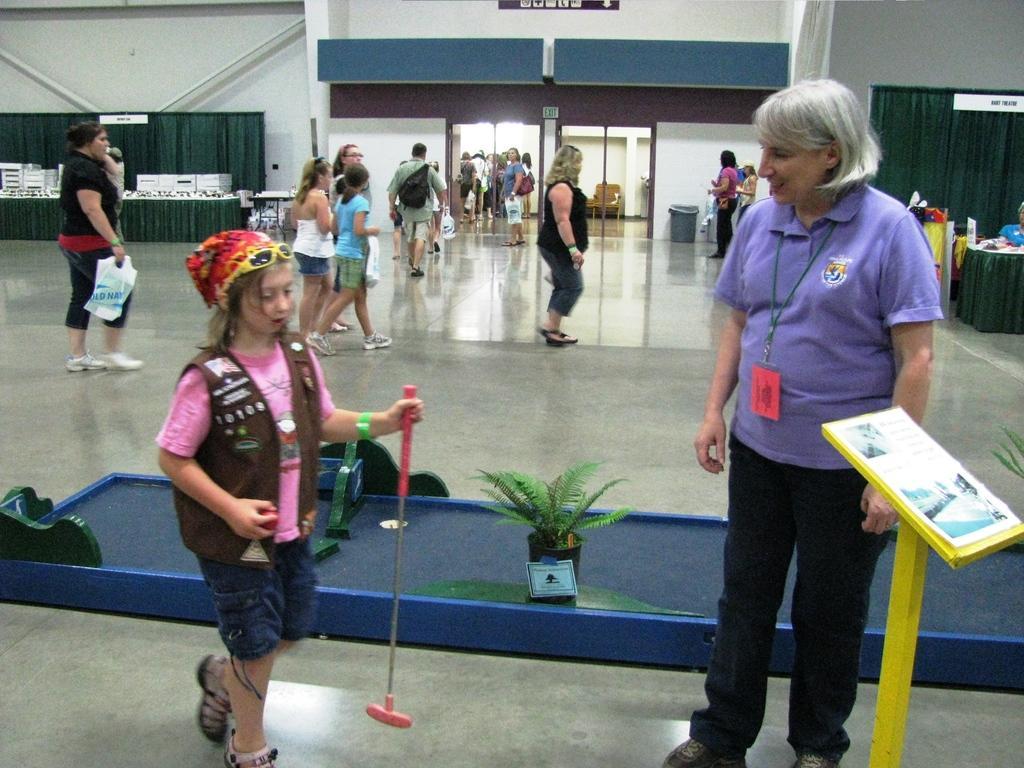Describe this image in one or two sentences. The girl in the pink t-shirt is holding a ball and stick in her hands. In front of her, woman in violet t-shirt is standing beside the podium. In between them, we see a flower pot. Behind them, we see people are walking. On the right corner of the picture, we see a table on which paper and blue bag are placed. Behind that, we see a green color curtain. In the background, we see a sheet in green color and a table. We even see white wall and door. This picture might be clicked in the mall. 